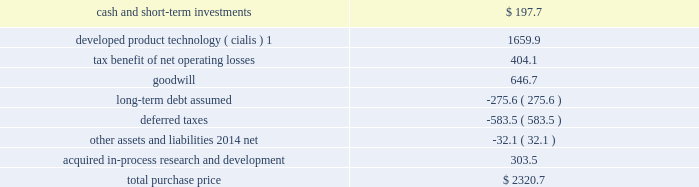Icos corporation on january 29 , 2007 , we acquired all of the outstanding common stock of icos corporation ( icos ) , our partner in the lilly icos llc joint venture for the manufacture and sale of cialis for the treatment of erectile dysfunction .
The acquisition brought the full value of cialis to us and enabled us to realize operational effi ciencies in the further development , marketing , and selling of this product .
The aggregate cash purchase price of approximately $ 2.3 bil- lion was fi nanced through borrowings .
The acquisition has been accounted for as a business combination under the purchase method of accounting , resulting in goodwill of $ 646.7 million .
No portion of this goodwill was deductible for tax purposes .
We determined the following estimated fair values for the assets acquired and liabilities assumed as of the date of acquisition .
Estimated fair value at january 29 , 2007 .
1this intangible asset will be amortized over the remaining expected patent lives of cialis in each country ; patent expiry dates range from 2015 to 2017 .
New indications for and formulations of the cialis compound in clinical testing at the time of the acquisition represented approximately 48 percent of the estimated fair value of the acquired ipr&d .
The remaining value of acquired ipr&d represented several other products in development , with no one asset comprising a signifi cant por- tion of this value .
The discount rate we used in valuing the acquired ipr&d projects was 20 percent , and the charge for acquired ipr&d of $ 303.5 million recorded in the fi rst quarter of 2007 was not deductible for tax purposes .
Other acquisitions during the second quarter of 2007 , we acquired all of the outstanding stock of both hypnion , inc .
( hypnion ) , a privately held neuroscience drug discovery company focused on sleep disorders , and ivy animal health , inc .
( ivy ) , a privately held applied research and pharmaceutical product development company focused on the animal health industry , for $ 445.0 million in cash .
The acquisition of hypnion provided us with a broader and more substantive presence in the area of sleep disorder research and ownership of hy10275 , a novel phase ii compound with a dual mechanism of action aimed at promoting better sleep onset and sleep maintenance .
This was hypnion 2019s only signifi cant asset .
For this acquisi- tion , we recorded an acquired ipr&d charge of $ 291.1 million , which was not deductible for tax purposes .
Because hypnion was a development-stage company , the transaction was accounted for as an acquisition of assets rather than as a business combination and , therefore , goodwill was not recorded .
The acquisition of ivy provides us with products that complement those of our animal health business .
This acquisition has been accounted for as a business combination under the purchase method of accounting .
We allocated $ 88.7 million of the purchase price to other identifi able intangible assets , primarily related to marketed products , $ 37.0 million to acquired ipr&d , and $ 25.0 million to goodwill .
The other identifi able intangible assets are being amortized over their estimated remaining useful lives of 10 to 20 years .
The $ 37.0 million allocated to acquired ipr&d was charged to expense in the second quarter of 2007 .
Goodwill resulting from this acquisition was fully allocated to the animal health business segment .
The amount allocated to each of the intangible assets acquired , including goodwill of $ 25.0 million and the acquired ipr&d of $ 37.0 million , was deductible for tax purposes .
Product acquisitions in june 2008 , we entered into a licensing and development agreement with transpharma medical ltd .
( trans- pharma ) to acquire rights to its product and related drug delivery system for the treatment of osteoporosis .
The product , which is administered transdermally using transpharma 2019s proprietary technology , was in phase ii clinical testing , and had no alternative future use .
Under the arrangement , we also gained non-exclusive access to trans- pharma 2019s viaderm drug delivery system for the product .
As with many development-phase products , launch of the .
At january 29 , 2007 what was the percent of the estimated fair value of tax benefit of net operating losses to the total purchase price? 
Rationale: the total purchase price was made of 27.9% of the tax benefit of net operating losses
Computations: (404.1 / 2320.7)
Answer: 0.17413. 